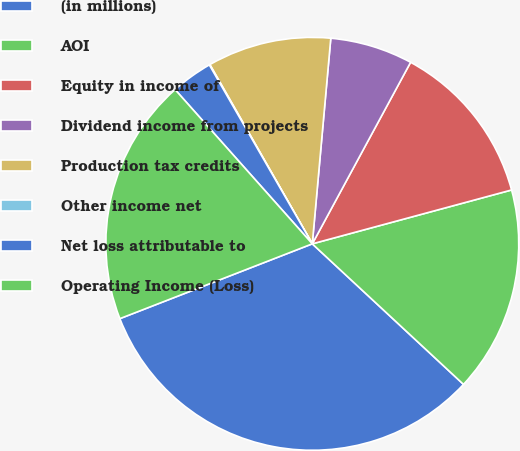<chart> <loc_0><loc_0><loc_500><loc_500><pie_chart><fcel>(in millions)<fcel>AOI<fcel>Equity in income of<fcel>Dividend income from projects<fcel>Production tax credits<fcel>Other income net<fcel>Net loss attributable to<fcel>Operating Income (Loss)<nl><fcel>32.18%<fcel>16.12%<fcel>12.9%<fcel>6.47%<fcel>9.69%<fcel>0.05%<fcel>3.26%<fcel>19.33%<nl></chart> 